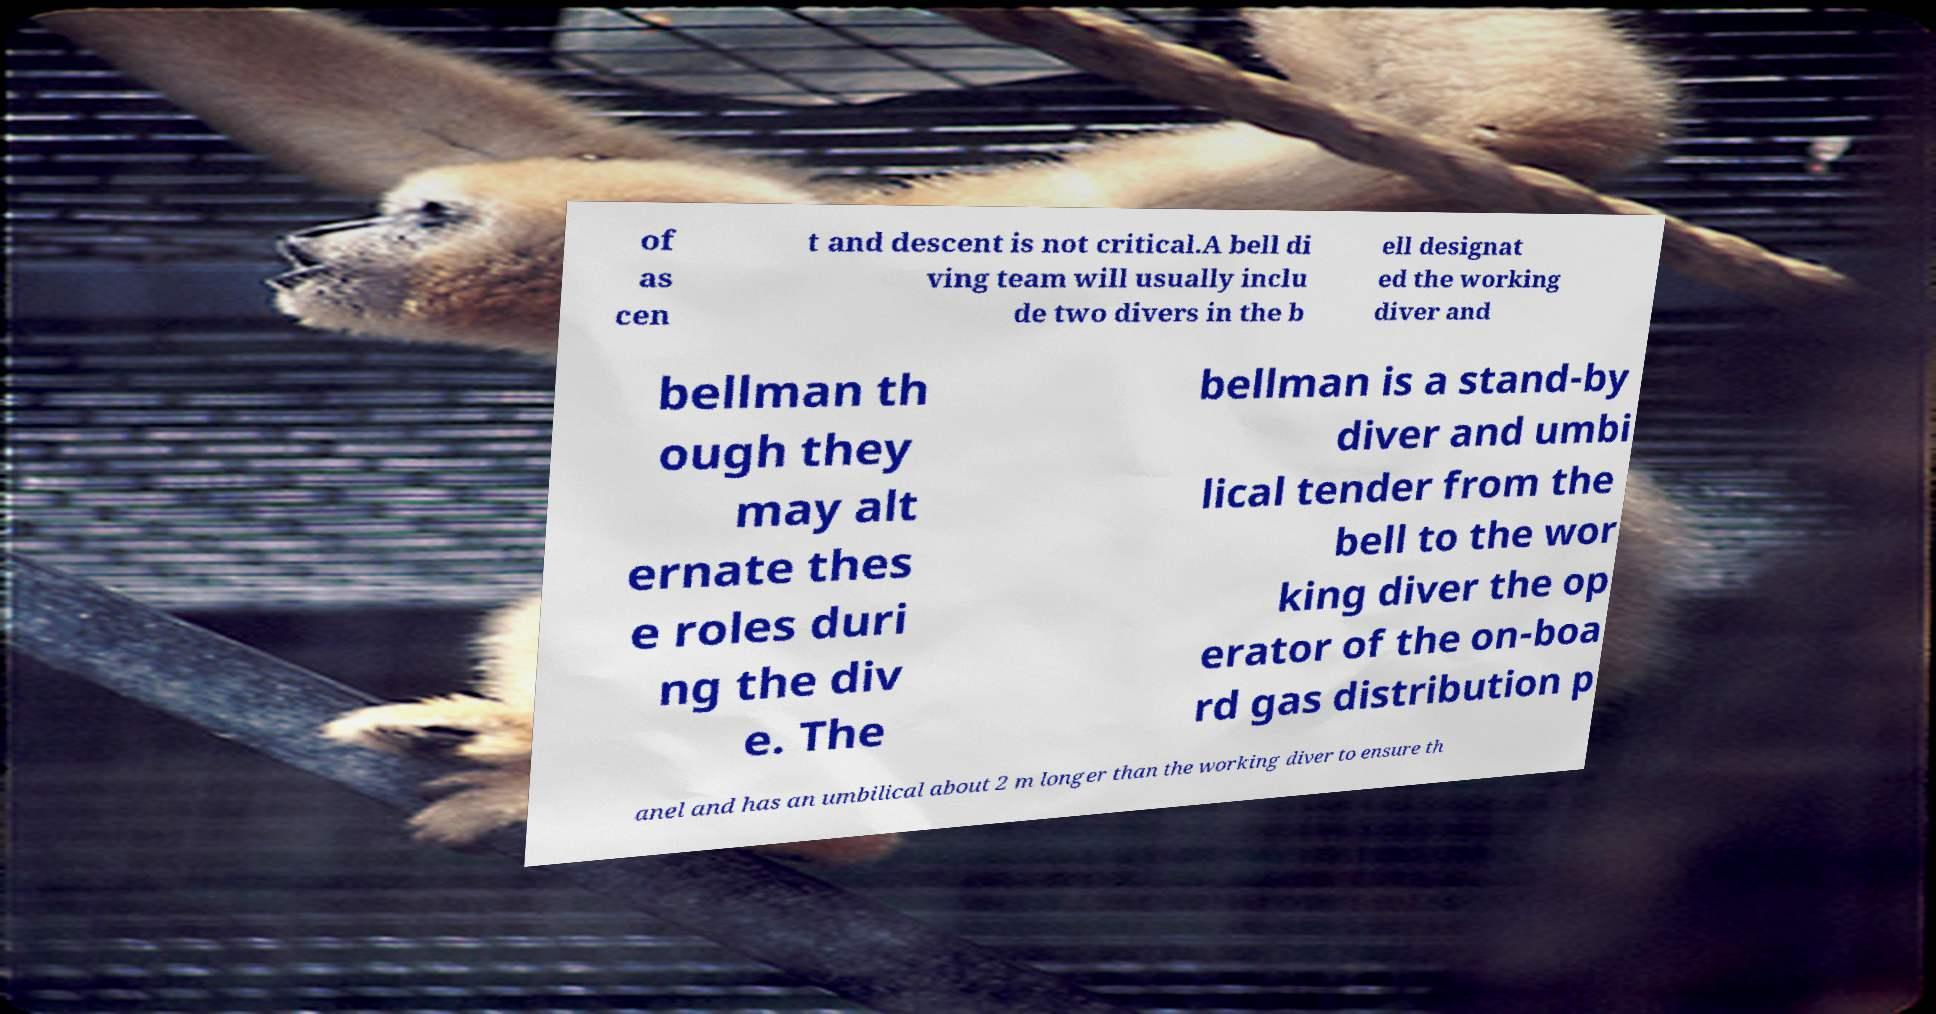Please identify and transcribe the text found in this image. of as cen t and descent is not critical.A bell di ving team will usually inclu de two divers in the b ell designat ed the working diver and bellman th ough they may alt ernate thes e roles duri ng the div e. The bellman is a stand-by diver and umbi lical tender from the bell to the wor king diver the op erator of the on-boa rd gas distribution p anel and has an umbilical about 2 m longer than the working diver to ensure th 